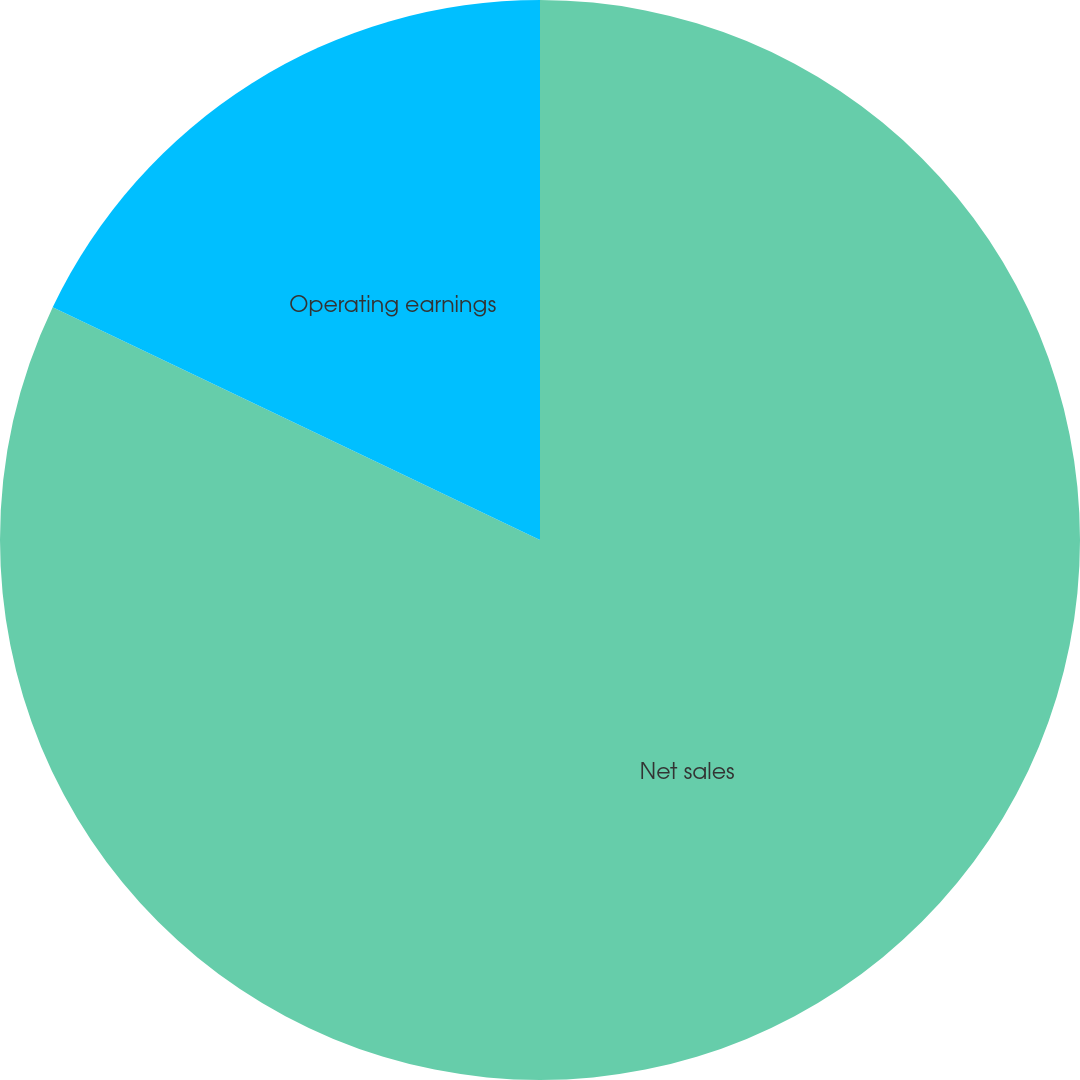Convert chart. <chart><loc_0><loc_0><loc_500><loc_500><pie_chart><fcel>Net sales<fcel>Operating earnings<nl><fcel>82.09%<fcel>17.91%<nl></chart> 